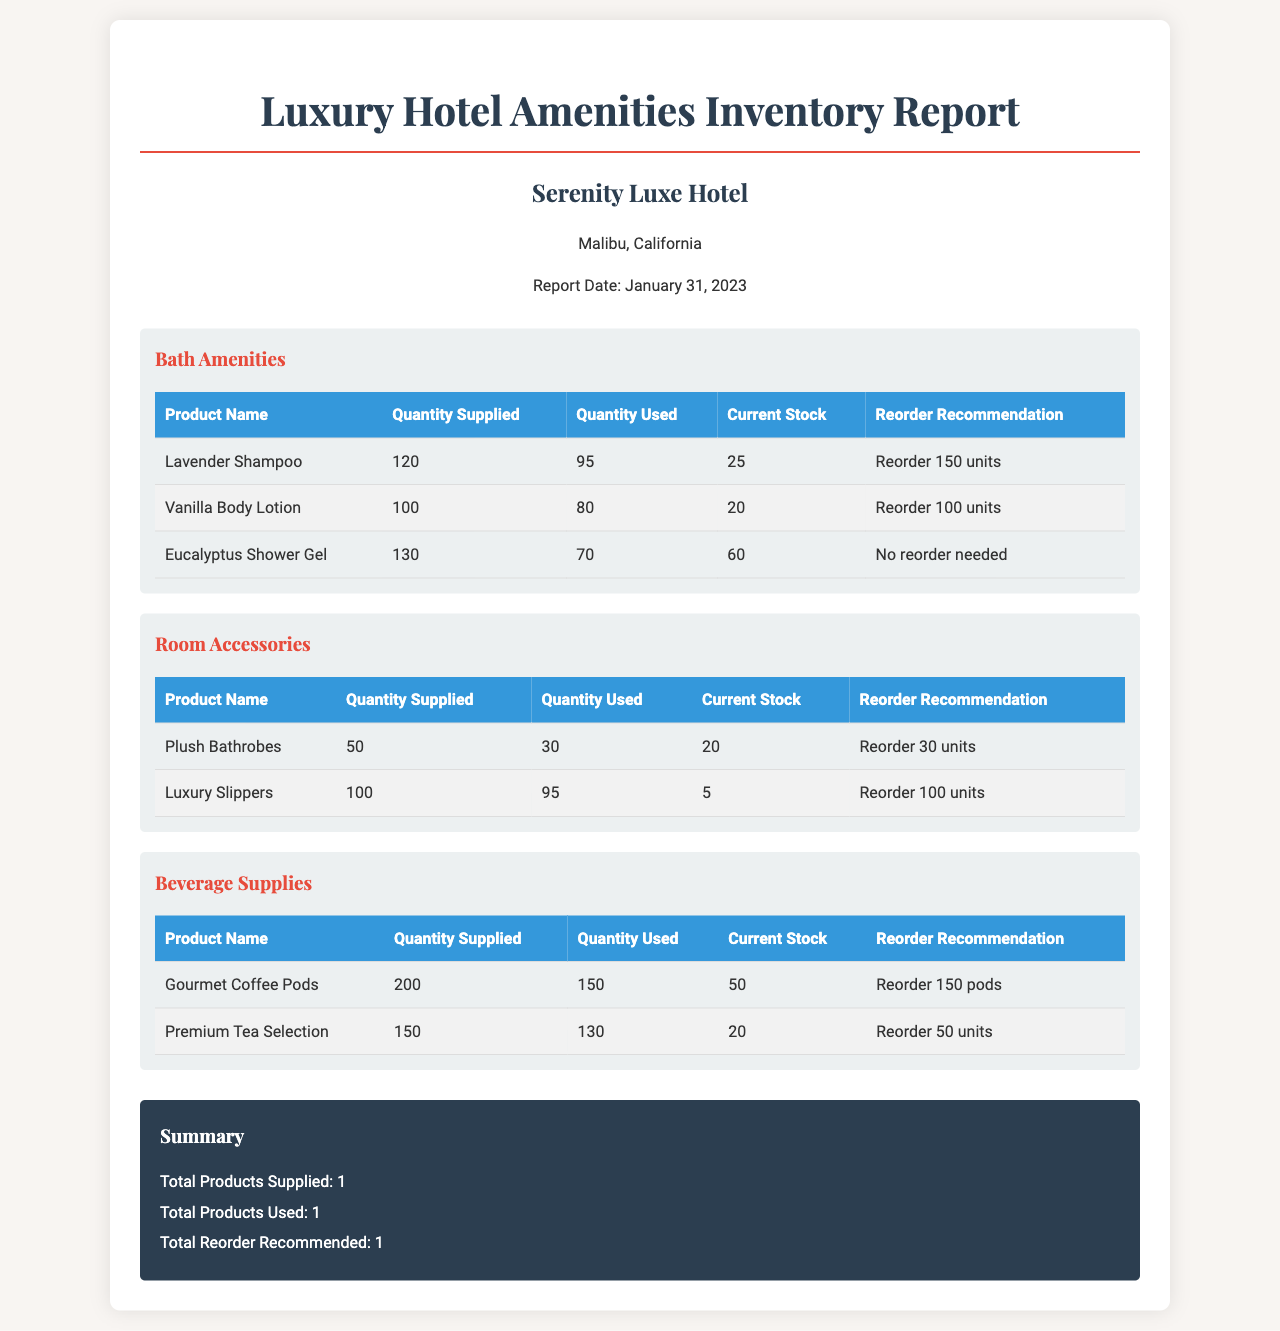what is the report date? The report date is specified at the top of the document as January 31, 2023.
Answer: January 31, 2023 how many units of Lavender Shampoo were supplied? The quantity supplied for Lavender Shampoo is listed in the Bath Amenities section as 120.
Answer: 120 what is the current stock of Luxury Slippers? The current stock of Luxury Slippers can be found in the Room Accessories table, which shows 5 remaining units.
Answer: 5 how many units of Eucalyptus Shower Gel need to be reordered? The Eucalyptus Shower Gel has no reorder needed, as stated in its row in the table.
Answer: No reorder needed what is the total quantity supplied for Beverage Supplies? The total quantity supplied for Beverage Supplies is the sum of the quantities of Gourmet Coffee Pods and Premium Tea Selection, which is 200 + 150.
Answer: 350 which product has the highest reorder recommendation? By comparing the reorder recommendations across the sections, Luxury Slippers have the highest recommendation of 100 units.
Answer: 100 units how many total products are used according to the summary? The summary section indicates the total number of products used in the report as 1.
Answer: 1 what is the name of the hotel listed in the document? The hotel name is mentioned in the hotel info section, which specifies "Serenity Luxe Hotel."
Answer: Serenity Luxe Hotel what category does Vanilla Body Lotion belong to? The Vanilla Body Lotion is listed under the Bath Amenities category presented in the document.
Answer: Bath Amenities 